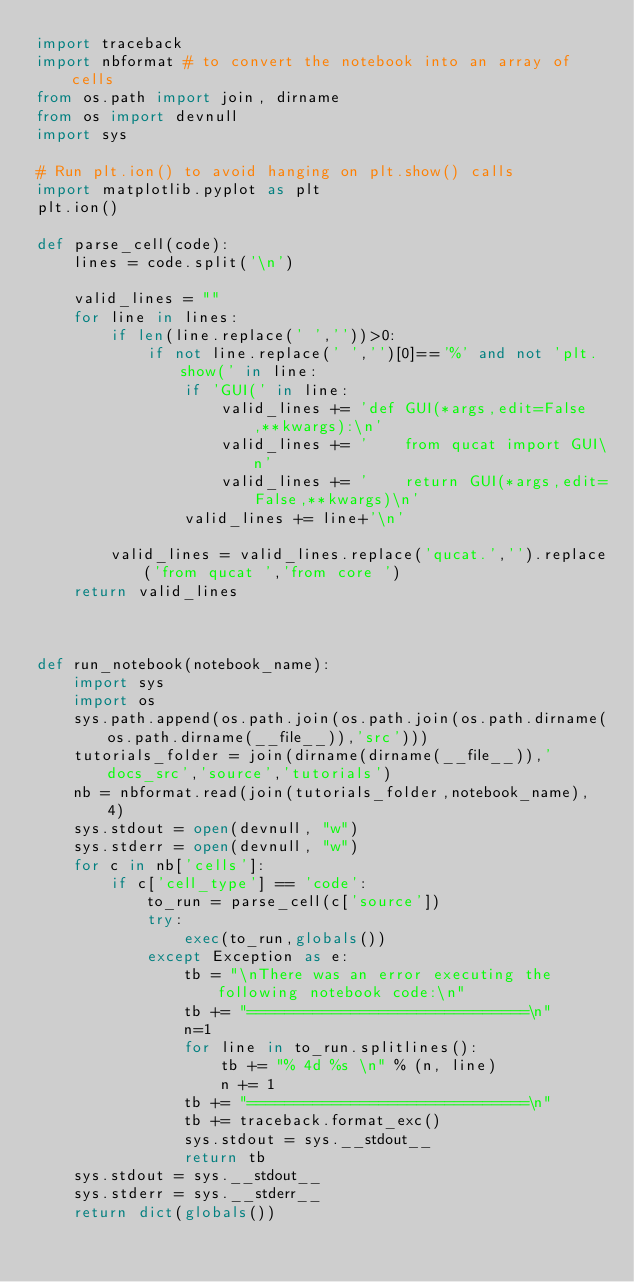Convert code to text. <code><loc_0><loc_0><loc_500><loc_500><_Python_>import traceback
import nbformat # to convert the notebook into an array of cells
from os.path import join, dirname
from os import devnull
import sys

# Run plt.ion() to avoid hanging on plt.show() calls
import matplotlib.pyplot as plt
plt.ion()

def parse_cell(code):
    lines = code.split('\n')

    valid_lines = ""
    for line in lines:
        if len(line.replace(' ',''))>0:
            if not line.replace(' ','')[0]=='%' and not 'plt.show(' in line:
                if 'GUI(' in line:
                    valid_lines += 'def GUI(*args,edit=False,**kwargs):\n'
                    valid_lines += '    from qucat import GUI\n'
                    valid_lines += '    return GUI(*args,edit=False,**kwargs)\n'
                valid_lines += line+'\n'

        valid_lines = valid_lines.replace('qucat.','').replace('from qucat ','from core ')
    return valid_lines



def run_notebook(notebook_name):
    import sys
    import os
    sys.path.append(os.path.join(os.path.join(os.path.dirname(os.path.dirname(__file__)),'src')))
    tutorials_folder = join(dirname(dirname(__file__)),'docs_src','source','tutorials')
    nb = nbformat.read(join(tutorials_folder,notebook_name), 4)
    sys.stdout = open(devnull, "w")
    sys.stderr = open(devnull, "w")
    for c in nb['cells']:
        if c['cell_type'] == 'code':
            to_run = parse_cell(c['source'])
            try: 
                exec(to_run,globals())
            except Exception as e:
                tb = "\nThere was an error executing the following notebook code:\n"
                tb += "==============================\n"
                n=1
                for line in to_run.splitlines():
                    tb += "% 4d %s \n" % (n, line)
                    n += 1
                tb += "==============================\n"
                tb += traceback.format_exc()
                sys.stdout = sys.__stdout__
                return tb
    sys.stdout = sys.__stdout__
    sys.stderr = sys.__stderr__
    return dict(globals())</code> 